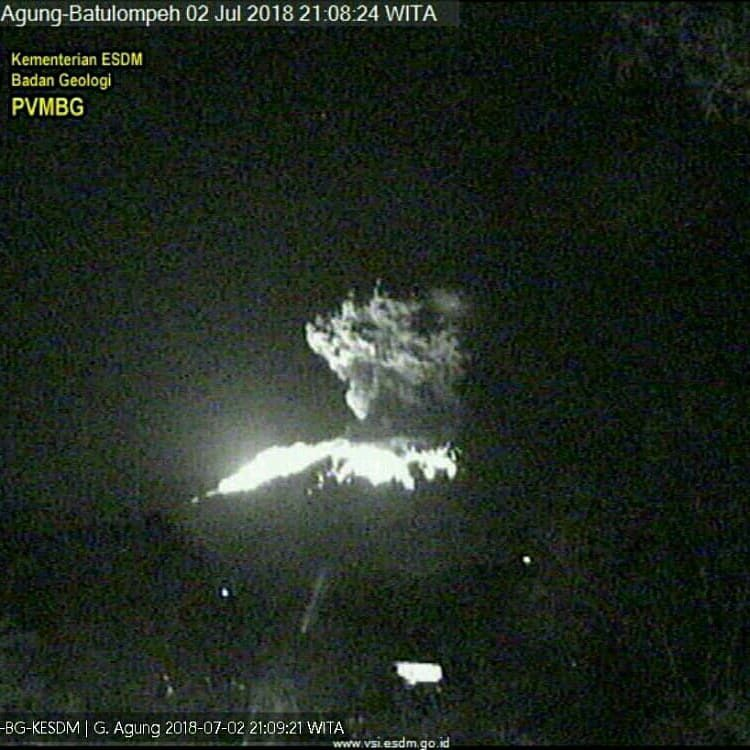How significant do you think this eruption is in terms of volcanic activity? Judging by the visible intensity of the eruption in the image, it seems to be a relatively significant event. The bright glow indicates a substantial emission of lava or pyroclastic material. The presence of such luminous activity at night suggests that this is more than just a minor release of volcanic gases. The size of the eruption column and the brightness of the lava flow are indicative of considerable volcanic activity, which could potentially have widespread impacts given the right conditions. 